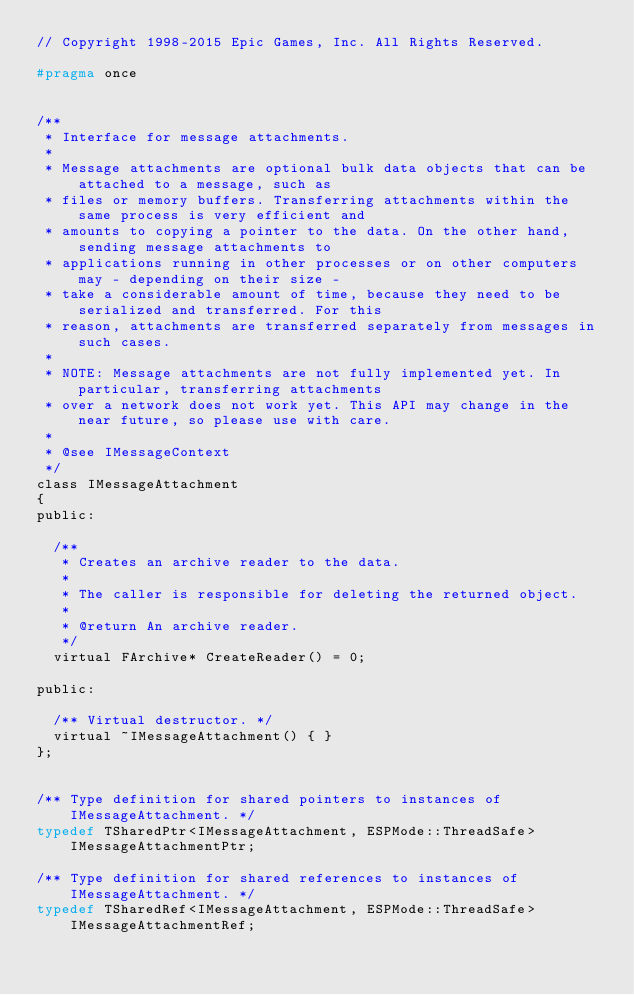Convert code to text. <code><loc_0><loc_0><loc_500><loc_500><_C_>// Copyright 1998-2015 Epic Games, Inc. All Rights Reserved.

#pragma once


/**
 * Interface for message attachments.
 *
 * Message attachments are optional bulk data objects that can be attached to a message, such as
 * files or memory buffers. Transferring attachments within the same process is very efficient and
 * amounts to copying a pointer to the data. On the other hand, sending message attachments to
 * applications running in other processes or on other computers may - depending on their size -
 * take a considerable amount of time, because they need to be serialized and transferred. For this
 * reason, attachments are transferred separately from messages in such cases.
 *
 * NOTE: Message attachments are not fully implemented yet. In particular, transferring attachments
 * over a network does not work yet. This API may change in the near future, so please use with care.
 *
 * @see IMessageContext
 */
class IMessageAttachment
{
public:

	/**
	 * Creates an archive reader to the data.
	 *
	 * The caller is responsible for deleting the returned object.
	 *
	 * @return An archive reader.
	 */
	virtual FArchive* CreateReader() = 0;

public:

	/** Virtual destructor. */
	virtual ~IMessageAttachment() { }
};


/** Type definition for shared pointers to instances of IMessageAttachment. */
typedef TSharedPtr<IMessageAttachment, ESPMode::ThreadSafe> IMessageAttachmentPtr;

/** Type definition for shared references to instances of IMessageAttachment. */
typedef TSharedRef<IMessageAttachment, ESPMode::ThreadSafe> IMessageAttachmentRef;
</code> 